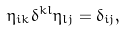<formula> <loc_0><loc_0><loc_500><loc_500>\eta _ { i k } \delta ^ { k l } \eta _ { l j } = \delta _ { i j } ,</formula> 